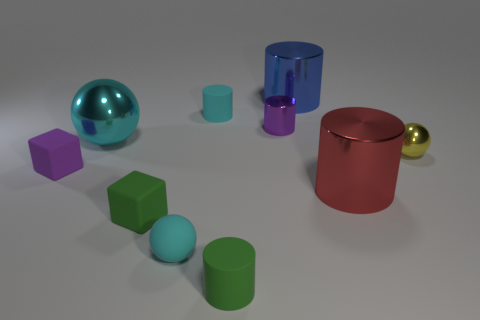Are there any shiny cylinders that are in front of the blue thing that is behind the rubber cylinder that is behind the tiny yellow thing?
Give a very brief answer. Yes. Is the number of tiny things that are in front of the small green block greater than the number of yellow things left of the cyan metal thing?
Give a very brief answer. Yes. There is a purple cylinder that is the same size as the green matte cylinder; what material is it?
Provide a succinct answer. Metal. What number of tiny things are either purple rubber things or cyan matte cylinders?
Your response must be concise. 2. Is the yellow metallic object the same shape as the cyan metal thing?
Keep it short and to the point. Yes. What number of large things are both in front of the blue metallic cylinder and behind the tiny cyan cylinder?
Your response must be concise. 0. Is there anything else that has the same color as the small metallic ball?
Ensure brevity in your answer.  No. The green object that is the same material as the tiny green cylinder is what shape?
Your answer should be compact. Cube. Do the red shiny cylinder and the purple metallic thing have the same size?
Your answer should be compact. No. Are the large cylinder behind the red metal thing and the green cube made of the same material?
Your response must be concise. No. 